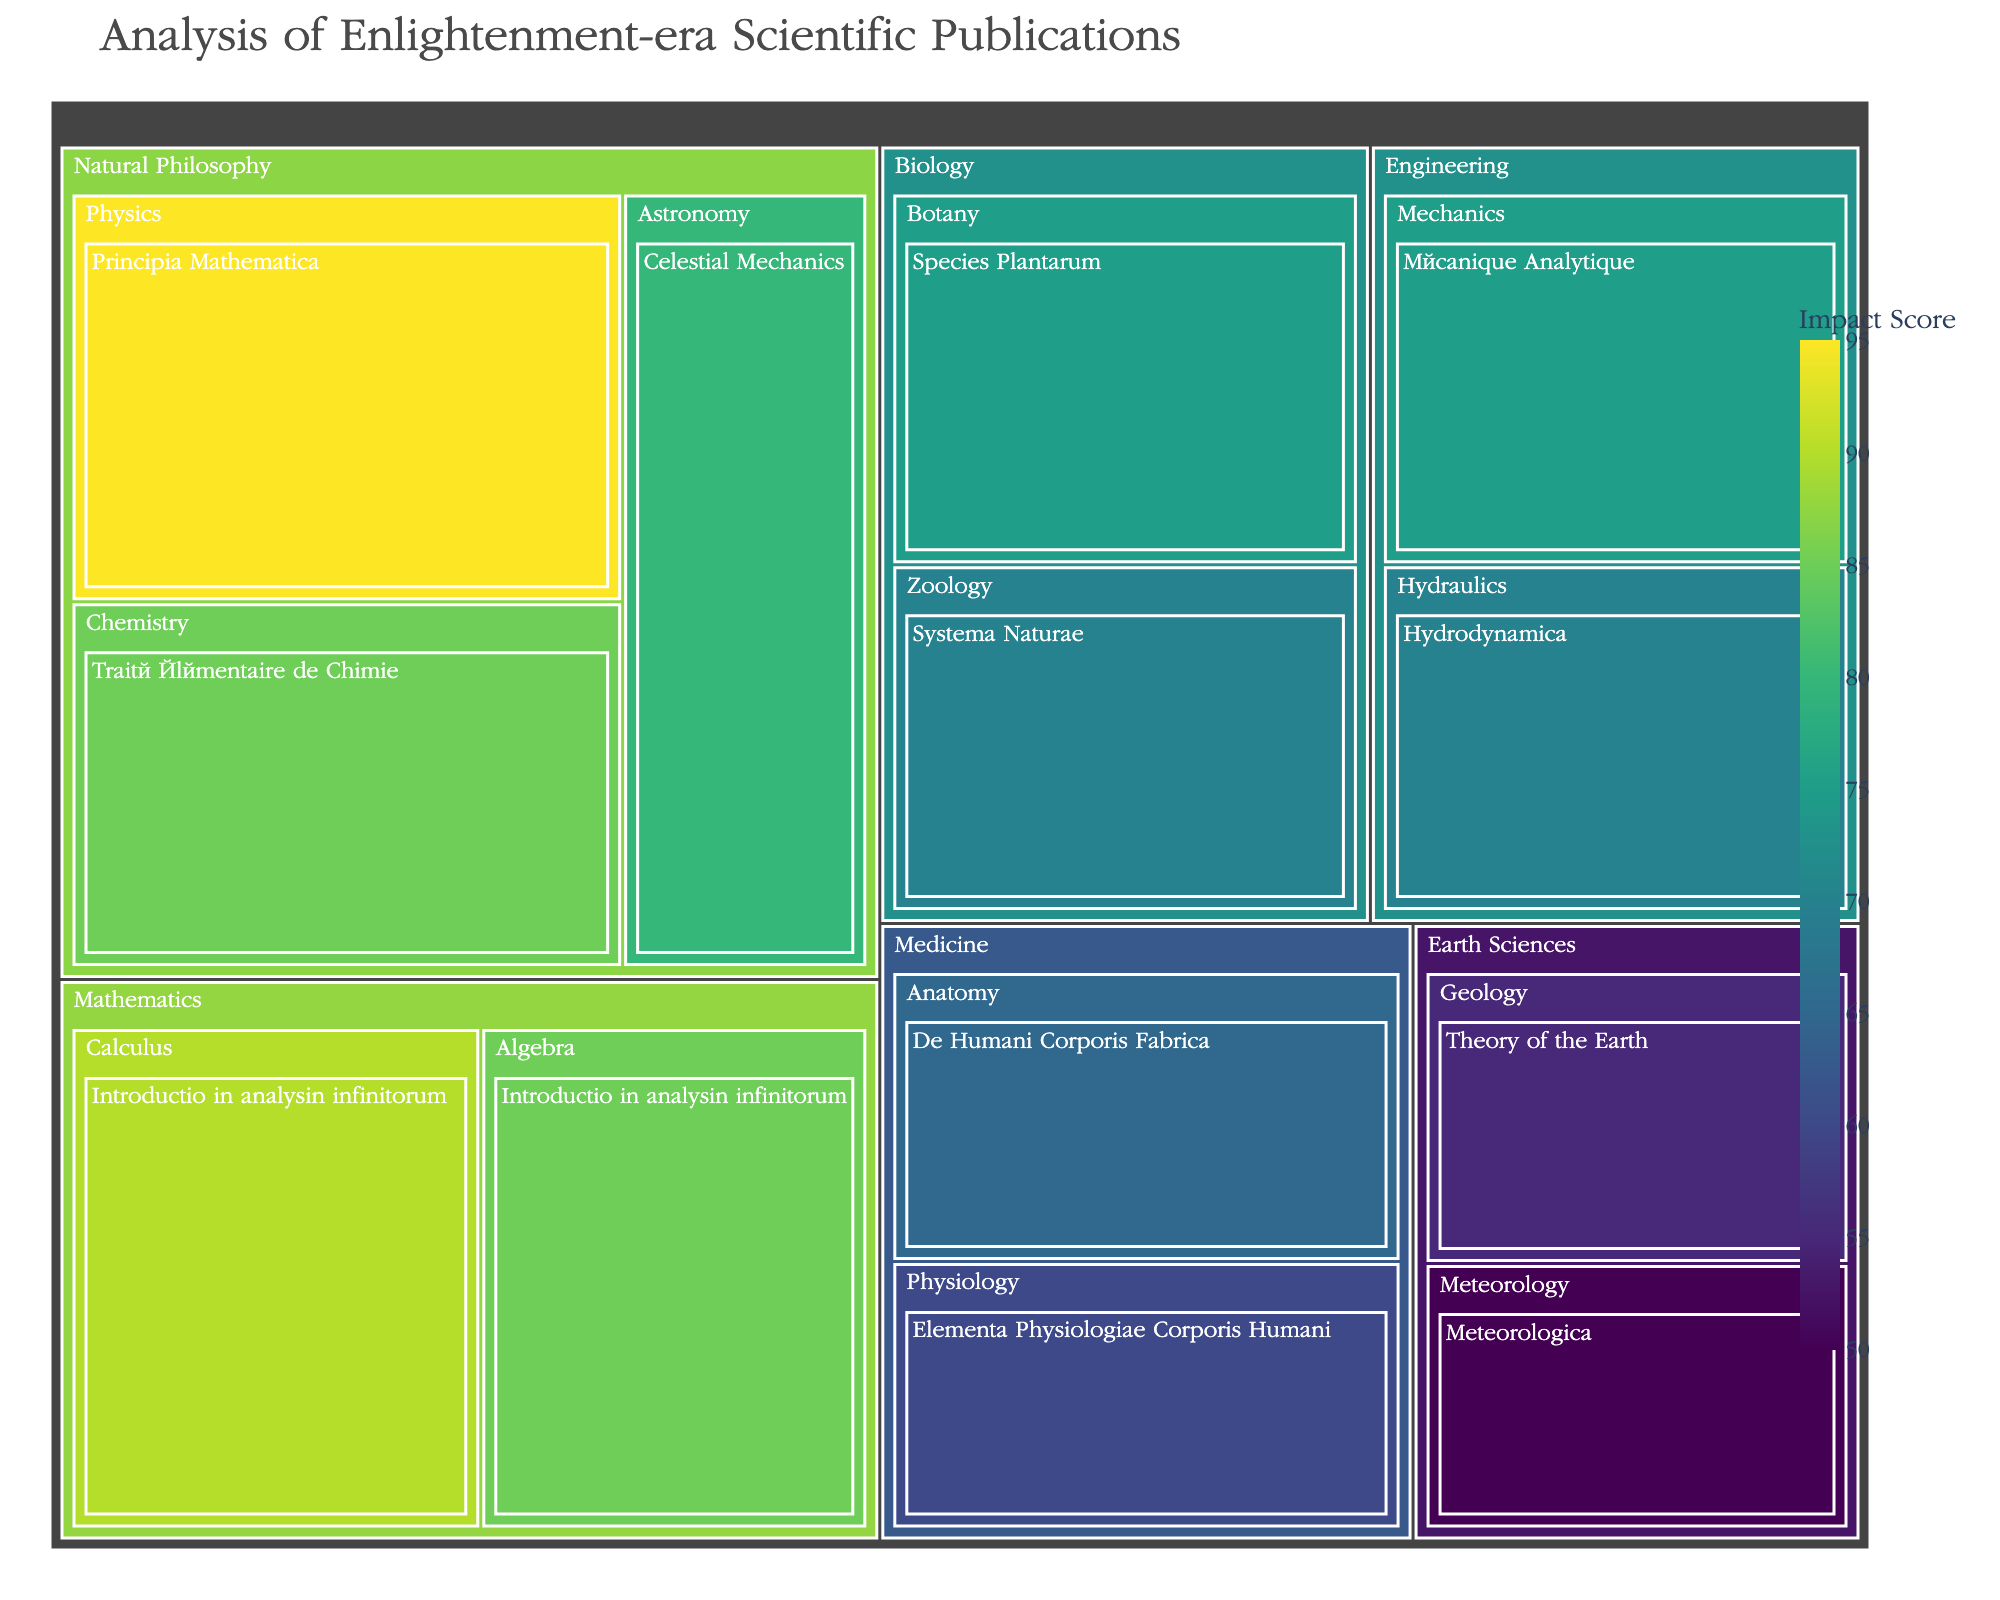1. What is the title of the figure? The title of the figure is prominently displayed at the top, which indicates the main subject of the visualization.
Answer: Analysis of Enlightenment-era Scientific Publications 2. Which publication has the highest impact score? By observing the color intensity and checking the impact values within the treemap, the publication with the highest impact score can be identified.
Answer: Principia Mathematica 3. List all the subfields under the "Medicine" field. Examine the hierarchical structure of the treemap under the "Medicine" field to identify the labeled subfields.
Answer: Anatomy, Physiology 4. What is the difference in impact score between "Introductio in analysin infinitorum" in Calculus and in Algebra? Refer to the impact scores of both instances of "Introductio in analysin infinitorum" in their respective subfields and compute the difference: 90 (Calculus) - 85 (Algebra).
Answer: 5 5. Which field has publications with the least average impact? Calculate the average impact scores for each field by dividing the sum of the impact scores by the number of publications for each field, and then identify the field with the lowest average.
Answer: Earth Sciences 6. Compare the highest impact scores for the "Biology" and "Engineering" fields. Which one is higher? Identify the highest impact scores for each field from the treemap and compare them: 75 (Biology) vs. 75 (Engineering).
Answer: They are equal 7. How many publications are listed under the "Natural Philosophy" field, and what is their combined impact score? Count each publication under the "Natural Philosophy" field and sum their impact scores: 95 + 80 + 85.
Answer: 3 publications, combined impact of 260 8. What does the color intensity in the treemap represent? The color intensity of the tiles in the treemap corresponds to the impact score, with a color scale showing higher impact scores in more intense colors.
Answer: Impact score 9. Which subfield within "Mathematics" has a higher combined impact score, and what is the combined score? Sum the impact scores of the publications in each subfield within "Mathematics" and compare them: Calculus (90) vs. Algebra (85).
Answer: Calculus with a combined score of 90 10. What range of impact scores is represented in the figure? Identify the minimum and maximum impact scores across all publications listed within the treemap: 50 to 95.
Answer: 50 to 95 